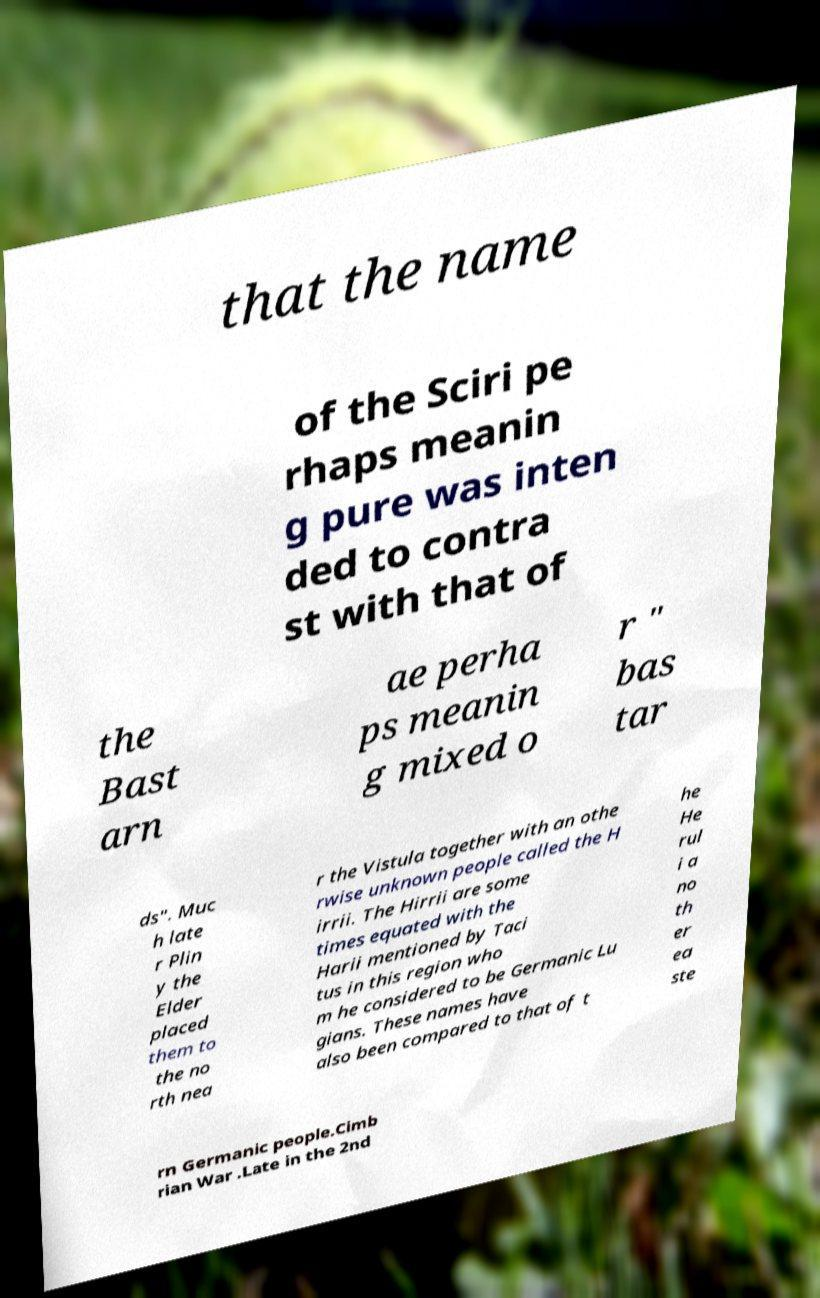For documentation purposes, I need the text within this image transcribed. Could you provide that? that the name of the Sciri pe rhaps meanin g pure was inten ded to contra st with that of the Bast arn ae perha ps meanin g mixed o r " bas tar ds". Muc h late r Plin y the Elder placed them to the no rth nea r the Vistula together with an othe rwise unknown people called the H irrii. The Hirrii are some times equated with the Harii mentioned by Taci tus in this region who m he considered to be Germanic Lu gians. These names have also been compared to that of t he He rul i a no th er ea ste rn Germanic people.Cimb rian War .Late in the 2nd 